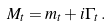Convert formula to latex. <formula><loc_0><loc_0><loc_500><loc_500>M _ { t } = m _ { t } + i \Gamma _ { t } \, .</formula> 